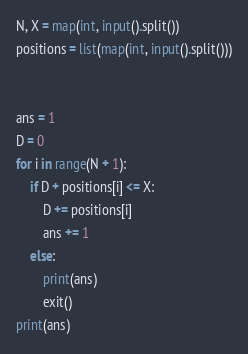<code> <loc_0><loc_0><loc_500><loc_500><_Python_>N, X = map(int, input().split())
positions = list(map(int, input().split()))


ans = 1
D = 0
for i in range(N + 1):
    if D + positions[i] <= X:
        D += positions[i]
        ans += 1
    else:
        print(ans)
        exit()
print(ans)
</code> 